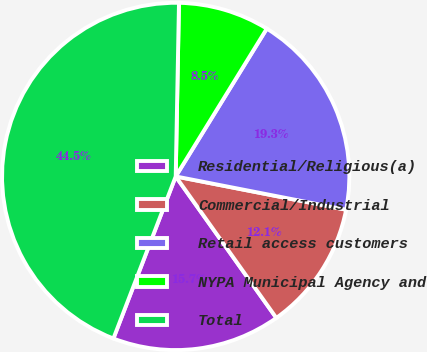Convert chart. <chart><loc_0><loc_0><loc_500><loc_500><pie_chart><fcel>Residential/Religious(a)<fcel>Commercial/Industrial<fcel>Retail access customers<fcel>NYPA Municipal Agency and<fcel>Total<nl><fcel>15.68%<fcel>12.09%<fcel>19.28%<fcel>8.49%<fcel>44.46%<nl></chart> 